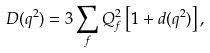Convert formula to latex. <formula><loc_0><loc_0><loc_500><loc_500>D ( q ^ { 2 } ) = 3 \sum _ { f } Q _ { f } ^ { 2 } \left [ 1 + d ( q ^ { 2 } ) \right ] ,</formula> 